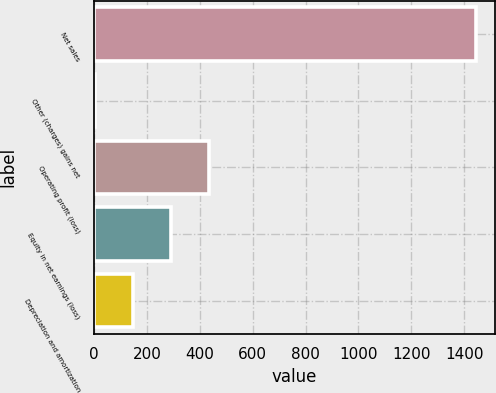Convert chart to OTSL. <chart><loc_0><loc_0><loc_500><loc_500><bar_chart><fcel>Net sales<fcel>Other (charges) gains net<fcel>Operating profit (loss)<fcel>Equity in net earnings (loss)<fcel>Depreciation and amortization<nl><fcel>1444<fcel>2<fcel>434.6<fcel>290.4<fcel>146.2<nl></chart> 